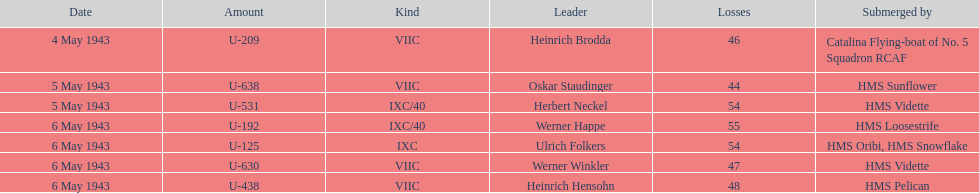Which ship sunk the most u-boats HMS Vidette. 